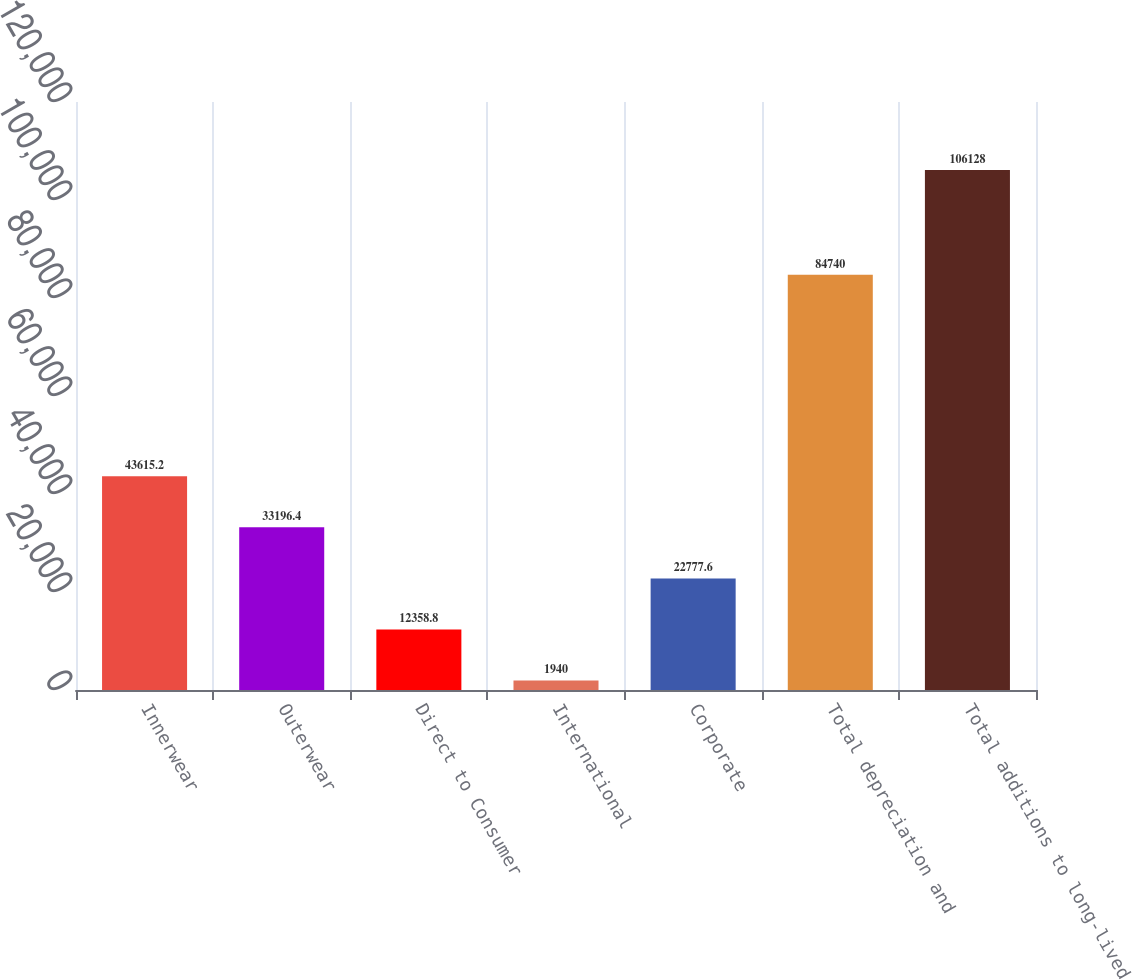Convert chart. <chart><loc_0><loc_0><loc_500><loc_500><bar_chart><fcel>Innerwear<fcel>Outerwear<fcel>Direct to Consumer<fcel>International<fcel>Corporate<fcel>Total depreciation and<fcel>Total additions to long-lived<nl><fcel>43615.2<fcel>33196.4<fcel>12358.8<fcel>1940<fcel>22777.6<fcel>84740<fcel>106128<nl></chart> 